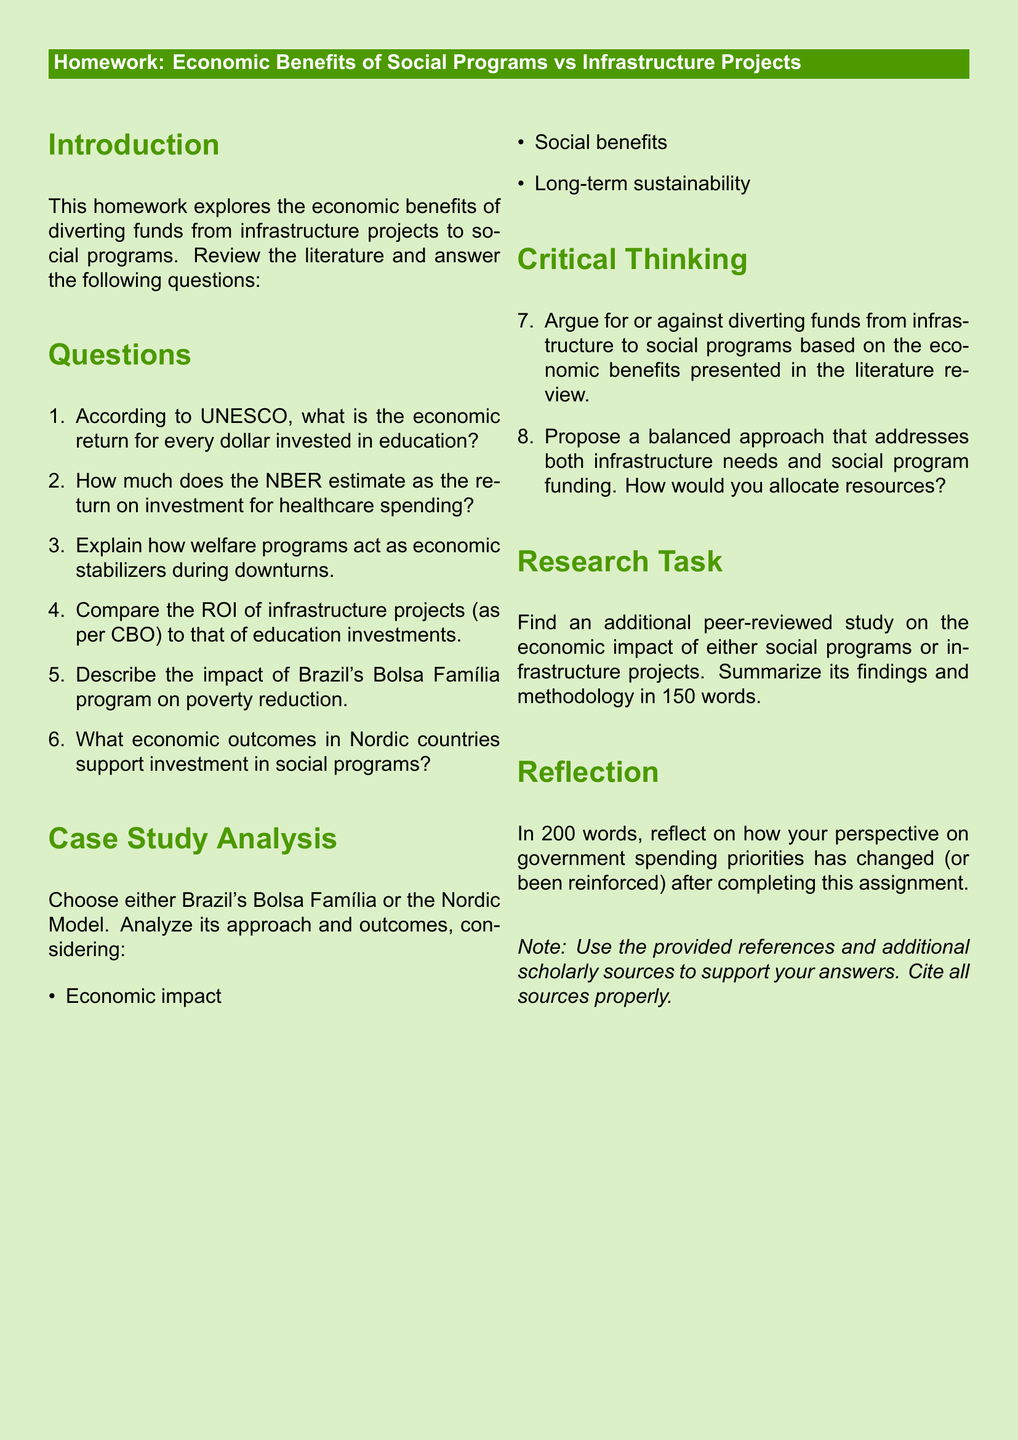what is the economic return for every dollar invested in education according to UNESCO? The economic return for every dollar invested in education is according to UNESCO, which is not specified in the text but implies a significant return.
Answer: significant return what is the estimated return on investment for healthcare spending according to NBER? The NBER provides an estimate for the ROI of healthcare spending, which is not explicitly stated in the document.
Answer: not explicitly stated how do welfare programs function during economic downturns? Welfare programs are described as economic stabilizers during downturns, implying a supportive role, but the specific mechanisms are not detailed.
Answer: economic stabilizers compare the ROI of infrastructure projects to education investments as per CBO. The document suggests a comparison of ROI between infrastructure projects and education investments, but specific figures or ratios are not provided.
Answer: not provided what is Brazil's Bolsa Família program known for? Brazil's Bolsa Família program is mentioned in the context of its impact on poverty reduction, but specific figures are not given in the document.
Answer: poverty reduction what are the economic outcomes in Nordic countries used to support investment in social programs? The document refers to economic outcomes in Nordic countries that support social program investment, but does not provide specific details or figures.
Answer: not provided what are the main focus areas of the case study analysis? The focus areas of the case study analysis are stated as economic impact, social benefits, and long-term sustainability.
Answer: economic impact, social benefits, long-term sustainability what is required in the research task? The research task requires finding an additional peer-reviewed study and summarizing its findings and methodology.
Answer: summarize findings and methodology how long should the reflection be? The reflection section specifies that it should be 200 words long.
Answer: 200 words 